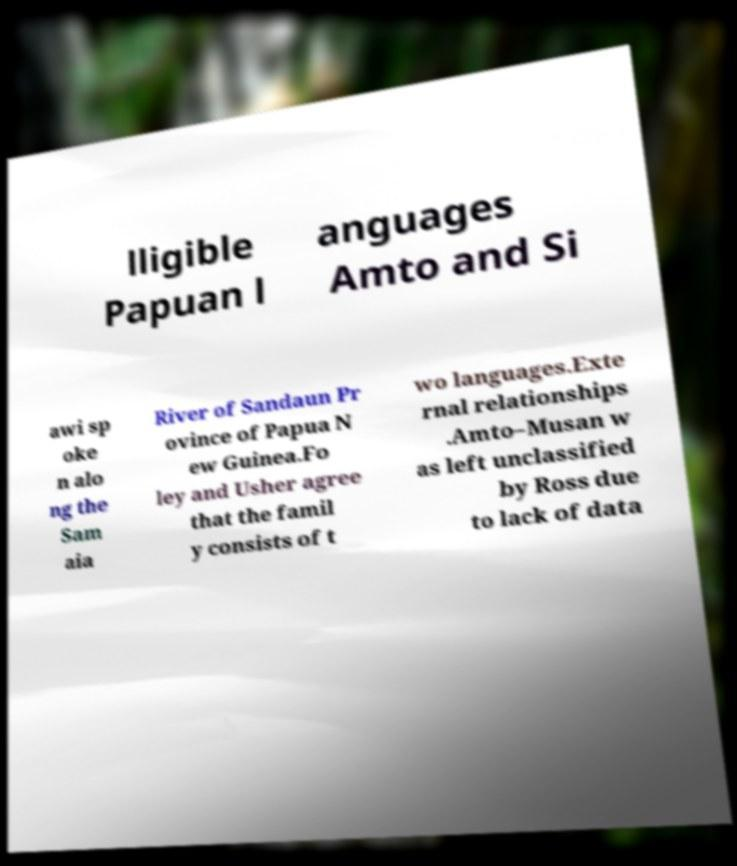What messages or text are displayed in this image? I need them in a readable, typed format. lligible Papuan l anguages Amto and Si awi sp oke n alo ng the Sam aia River of Sandaun Pr ovince of Papua N ew Guinea.Fo ley and Usher agree that the famil y consists of t wo languages.Exte rnal relationships .Amto–Musan w as left unclassified by Ross due to lack of data 